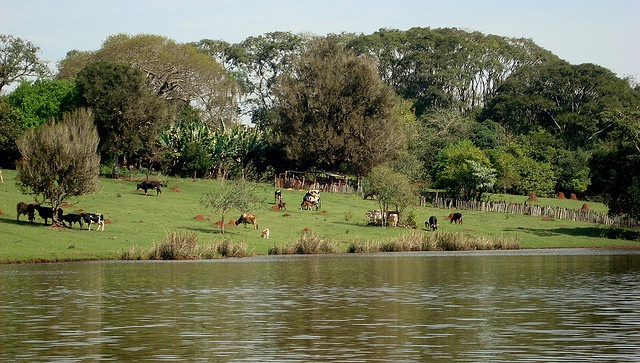Describe the objects in this image and their specific colors. I can see cow in lightgray, olive, and black tones, cow in lightgray, black, tan, khaki, and olive tones, cow in lightgray, olive, black, and maroon tones, cow in lightgray, black, darkgreen, and olive tones, and cow in lightgray, black, darkgreen, and olive tones in this image. 